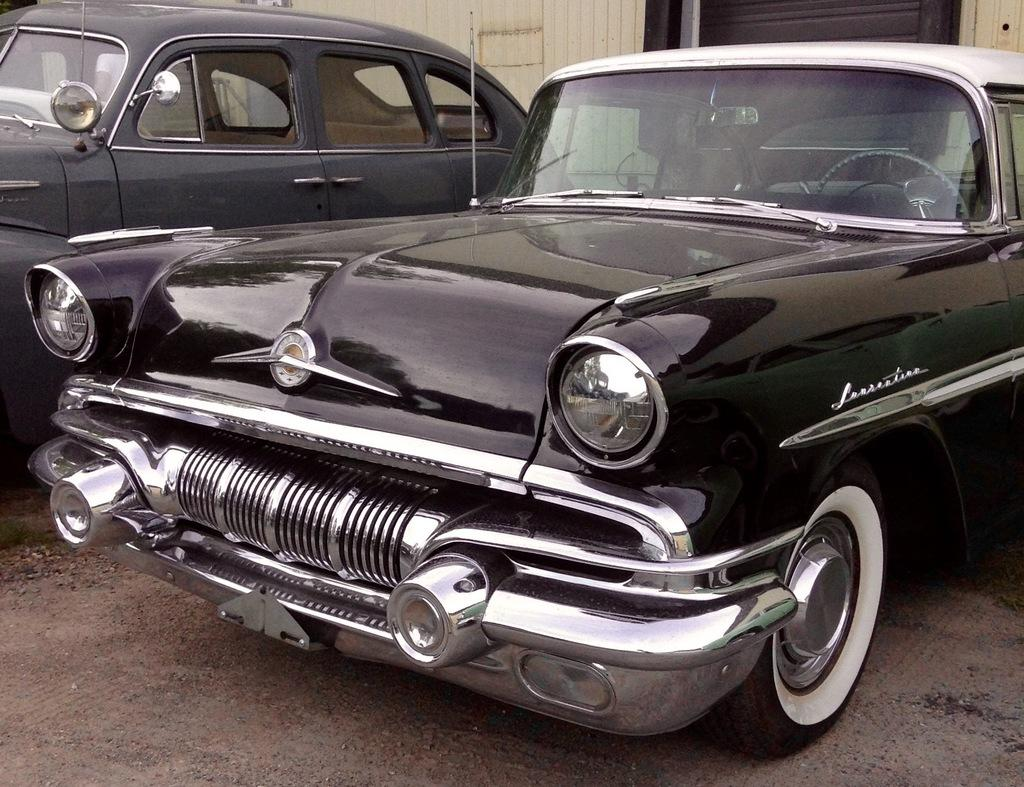How many cars can be seen on the road in the image? There are two cars on the road in the image. What colors are the cars? One car is gray, and the other car is black. What is visible in the background of the image? There is a wall in the background of the image. What color is the wall? The wall is in cream color. How does the growth of the plants affect the pail in the image? There is no pail or plants present in the image, so this question cannot be answered. 